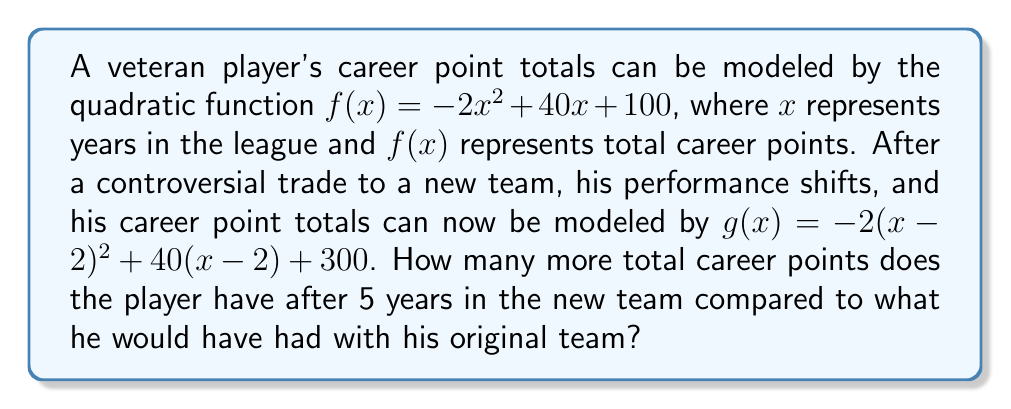What is the answer to this math problem? Let's approach this step-by-step:

1) First, we need to understand what the new function $g(x)$ represents:
   $g(x) = -2(x-2)^2 + 40(x-2) + 300$
   This is a horizontal translation of $f(x)$ by 2 units to the right, and a vertical translation by 200 units up.

2) To find the total points after 5 years in the new team, we need to calculate $g(7)$, because 5 years in the new team means 7 years total in the league:

   $g(7) = -2(7-2)^2 + 40(7-2) + 300$
         $= -2(5)^2 + 40(5) + 300$
         $= -50 + 200 + 300$
         $= 450$

3) To find what the total points would have been with the original team, we calculate $f(7)$:

   $f(7) = -2(7)^2 + 40(7) + 100$
         $= -98 + 280 + 100$
         $= 282$

4) The difference in total career points is:
   $450 - 282 = 168$
Answer: 168 points 